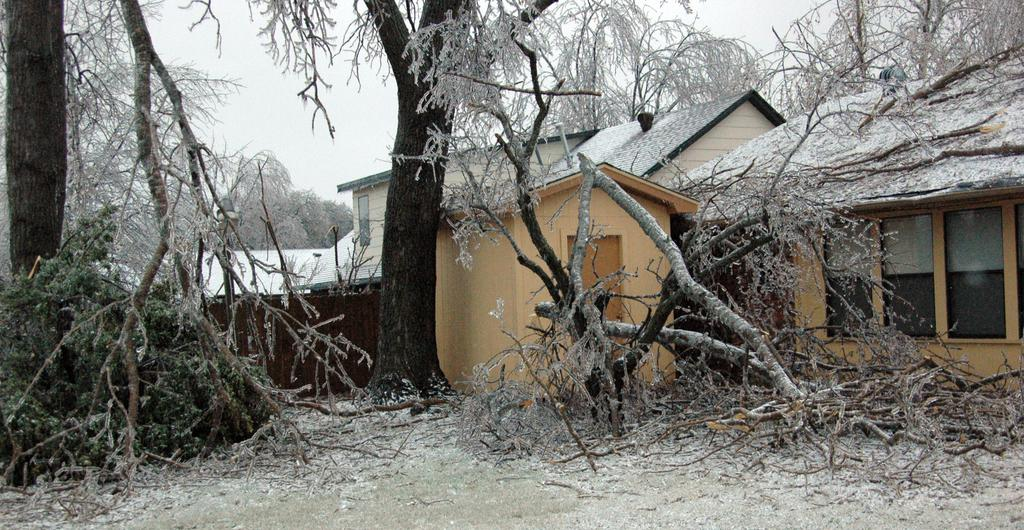What type of vegetation can be seen in the image? There are trees in the image. What part of the trees is visible in the image? There are branches in the image. What is covering the ground in the image? There is snow in the image. What type of structures can be seen in the image? There are houses in the image. What is visible in the background of the image? The sky is visible in the background of the image. How does the snow breathe in the image? Snow does not breathe; it is an inanimate substance. What way do the trees move in the image? The trees do not move in the image; they are stationary. 